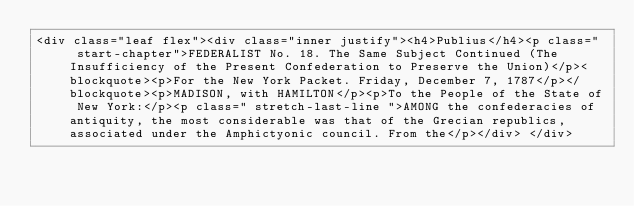Convert code to text. <code><loc_0><loc_0><loc_500><loc_500><_HTML_><div class="leaf flex"><div class="inner justify"><h4>Publius</h4><p class="  start-chapter">FEDERALIST No. 18. The Same Subject Continued (The Insufficiency of the Present Confederation to Preserve the Union)</p><blockquote><p>For the New York Packet. Friday, December 7, 1787</p></blockquote><p>MADISON, with HAMILTON</p><p>To the People of the State of New York:</p><p class=" stretch-last-line ">AMONG the confederacies of antiquity, the most considerable was that of the Grecian republics, associated under the Amphictyonic council. From the</p></div> </div></code> 